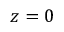Convert formula to latex. <formula><loc_0><loc_0><loc_500><loc_500>z = 0</formula> 